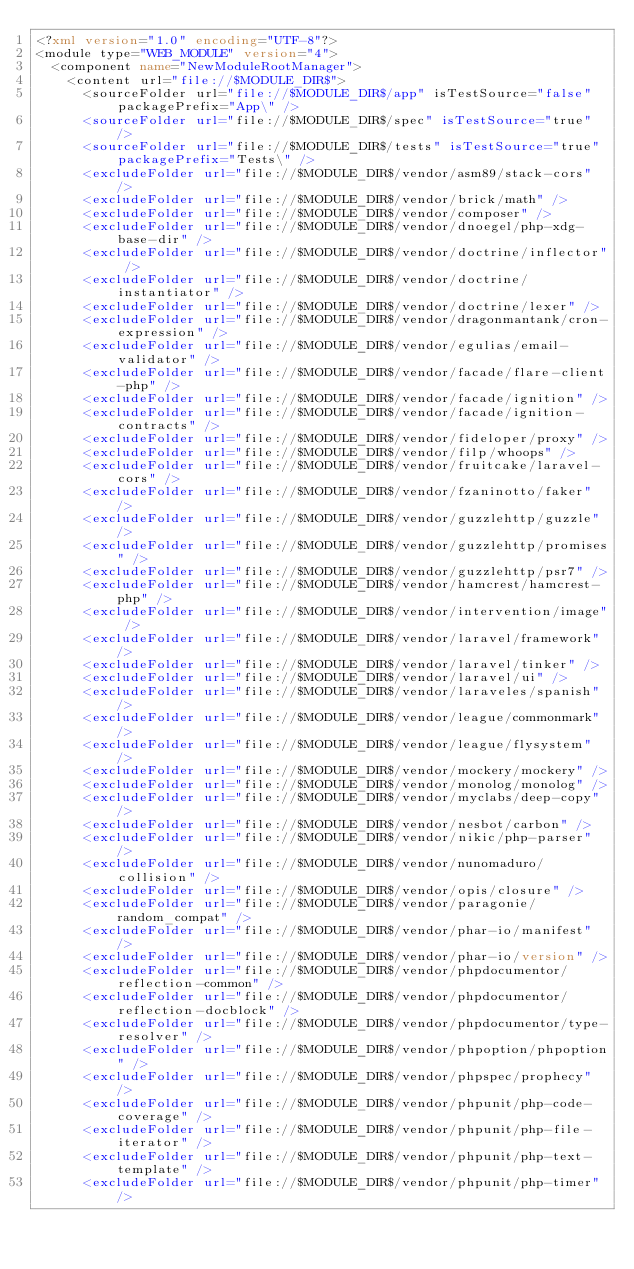<code> <loc_0><loc_0><loc_500><loc_500><_XML_><?xml version="1.0" encoding="UTF-8"?>
<module type="WEB_MODULE" version="4">
  <component name="NewModuleRootManager">
    <content url="file://$MODULE_DIR$">
      <sourceFolder url="file://$MODULE_DIR$/app" isTestSource="false" packagePrefix="App\" />
      <sourceFolder url="file://$MODULE_DIR$/spec" isTestSource="true" />
      <sourceFolder url="file://$MODULE_DIR$/tests" isTestSource="true" packagePrefix="Tests\" />
      <excludeFolder url="file://$MODULE_DIR$/vendor/asm89/stack-cors" />
      <excludeFolder url="file://$MODULE_DIR$/vendor/brick/math" />
      <excludeFolder url="file://$MODULE_DIR$/vendor/composer" />
      <excludeFolder url="file://$MODULE_DIR$/vendor/dnoegel/php-xdg-base-dir" />
      <excludeFolder url="file://$MODULE_DIR$/vendor/doctrine/inflector" />
      <excludeFolder url="file://$MODULE_DIR$/vendor/doctrine/instantiator" />
      <excludeFolder url="file://$MODULE_DIR$/vendor/doctrine/lexer" />
      <excludeFolder url="file://$MODULE_DIR$/vendor/dragonmantank/cron-expression" />
      <excludeFolder url="file://$MODULE_DIR$/vendor/egulias/email-validator" />
      <excludeFolder url="file://$MODULE_DIR$/vendor/facade/flare-client-php" />
      <excludeFolder url="file://$MODULE_DIR$/vendor/facade/ignition" />
      <excludeFolder url="file://$MODULE_DIR$/vendor/facade/ignition-contracts" />
      <excludeFolder url="file://$MODULE_DIR$/vendor/fideloper/proxy" />
      <excludeFolder url="file://$MODULE_DIR$/vendor/filp/whoops" />
      <excludeFolder url="file://$MODULE_DIR$/vendor/fruitcake/laravel-cors" />
      <excludeFolder url="file://$MODULE_DIR$/vendor/fzaninotto/faker" />
      <excludeFolder url="file://$MODULE_DIR$/vendor/guzzlehttp/guzzle" />
      <excludeFolder url="file://$MODULE_DIR$/vendor/guzzlehttp/promises" />
      <excludeFolder url="file://$MODULE_DIR$/vendor/guzzlehttp/psr7" />
      <excludeFolder url="file://$MODULE_DIR$/vendor/hamcrest/hamcrest-php" />
      <excludeFolder url="file://$MODULE_DIR$/vendor/intervention/image" />
      <excludeFolder url="file://$MODULE_DIR$/vendor/laravel/framework" />
      <excludeFolder url="file://$MODULE_DIR$/vendor/laravel/tinker" />
      <excludeFolder url="file://$MODULE_DIR$/vendor/laravel/ui" />
      <excludeFolder url="file://$MODULE_DIR$/vendor/laraveles/spanish" />
      <excludeFolder url="file://$MODULE_DIR$/vendor/league/commonmark" />
      <excludeFolder url="file://$MODULE_DIR$/vendor/league/flysystem" />
      <excludeFolder url="file://$MODULE_DIR$/vendor/mockery/mockery" />
      <excludeFolder url="file://$MODULE_DIR$/vendor/monolog/monolog" />
      <excludeFolder url="file://$MODULE_DIR$/vendor/myclabs/deep-copy" />
      <excludeFolder url="file://$MODULE_DIR$/vendor/nesbot/carbon" />
      <excludeFolder url="file://$MODULE_DIR$/vendor/nikic/php-parser" />
      <excludeFolder url="file://$MODULE_DIR$/vendor/nunomaduro/collision" />
      <excludeFolder url="file://$MODULE_DIR$/vendor/opis/closure" />
      <excludeFolder url="file://$MODULE_DIR$/vendor/paragonie/random_compat" />
      <excludeFolder url="file://$MODULE_DIR$/vendor/phar-io/manifest" />
      <excludeFolder url="file://$MODULE_DIR$/vendor/phar-io/version" />
      <excludeFolder url="file://$MODULE_DIR$/vendor/phpdocumentor/reflection-common" />
      <excludeFolder url="file://$MODULE_DIR$/vendor/phpdocumentor/reflection-docblock" />
      <excludeFolder url="file://$MODULE_DIR$/vendor/phpdocumentor/type-resolver" />
      <excludeFolder url="file://$MODULE_DIR$/vendor/phpoption/phpoption" />
      <excludeFolder url="file://$MODULE_DIR$/vendor/phpspec/prophecy" />
      <excludeFolder url="file://$MODULE_DIR$/vendor/phpunit/php-code-coverage" />
      <excludeFolder url="file://$MODULE_DIR$/vendor/phpunit/php-file-iterator" />
      <excludeFolder url="file://$MODULE_DIR$/vendor/phpunit/php-text-template" />
      <excludeFolder url="file://$MODULE_DIR$/vendor/phpunit/php-timer" /></code> 